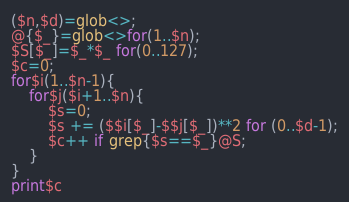Convert code to text. <code><loc_0><loc_0><loc_500><loc_500><_Perl_>($n,$d)=glob<>;
@{$_}=glob<>for(1..$n);
$S[$_]=$_*$_ for(0..127);
$c=0;
for$i(1..$n-1){
    for$j($i+1..$n){
        $s=0;
        $s += ($$i[$_]-$$j[$_])**2 for (0..$d-1);
        $c++ if grep{$s==$_}@S;
    }
}
print$c</code> 